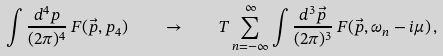<formula> <loc_0><loc_0><loc_500><loc_500>\int \frac { d ^ { 4 } p } { ( 2 \pi ) ^ { 4 } } \, F ( \vec { p } , p _ { 4 } ) \quad \to \quad T \sum _ { n = - \infty } ^ { \infty } \int \frac { d ^ { 3 } \vec { p } } { ( 2 \pi ) ^ { 3 } } \, F ( \vec { p } , \omega _ { n } - i \mu ) \, ,</formula> 